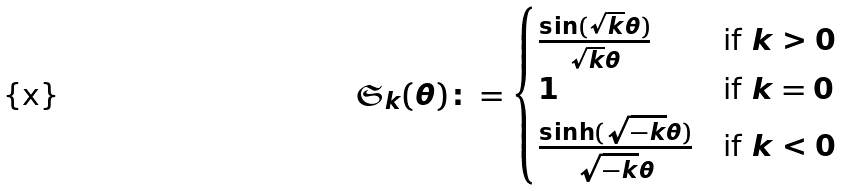<formula> <loc_0><loc_0><loc_500><loc_500>\mathfrak { S } _ { k } ( \theta ) \colon = \begin{cases} \frac { \sin ( \sqrt { k } \theta ) } { \sqrt { k } \theta } & \text {if $k>0$} \\ 1 & \text {if $k=0$} \\ \frac { \sinh ( \sqrt { - k } \theta ) } { \sqrt { - k } \theta } & \text {if $k<0$} \end{cases}</formula> 